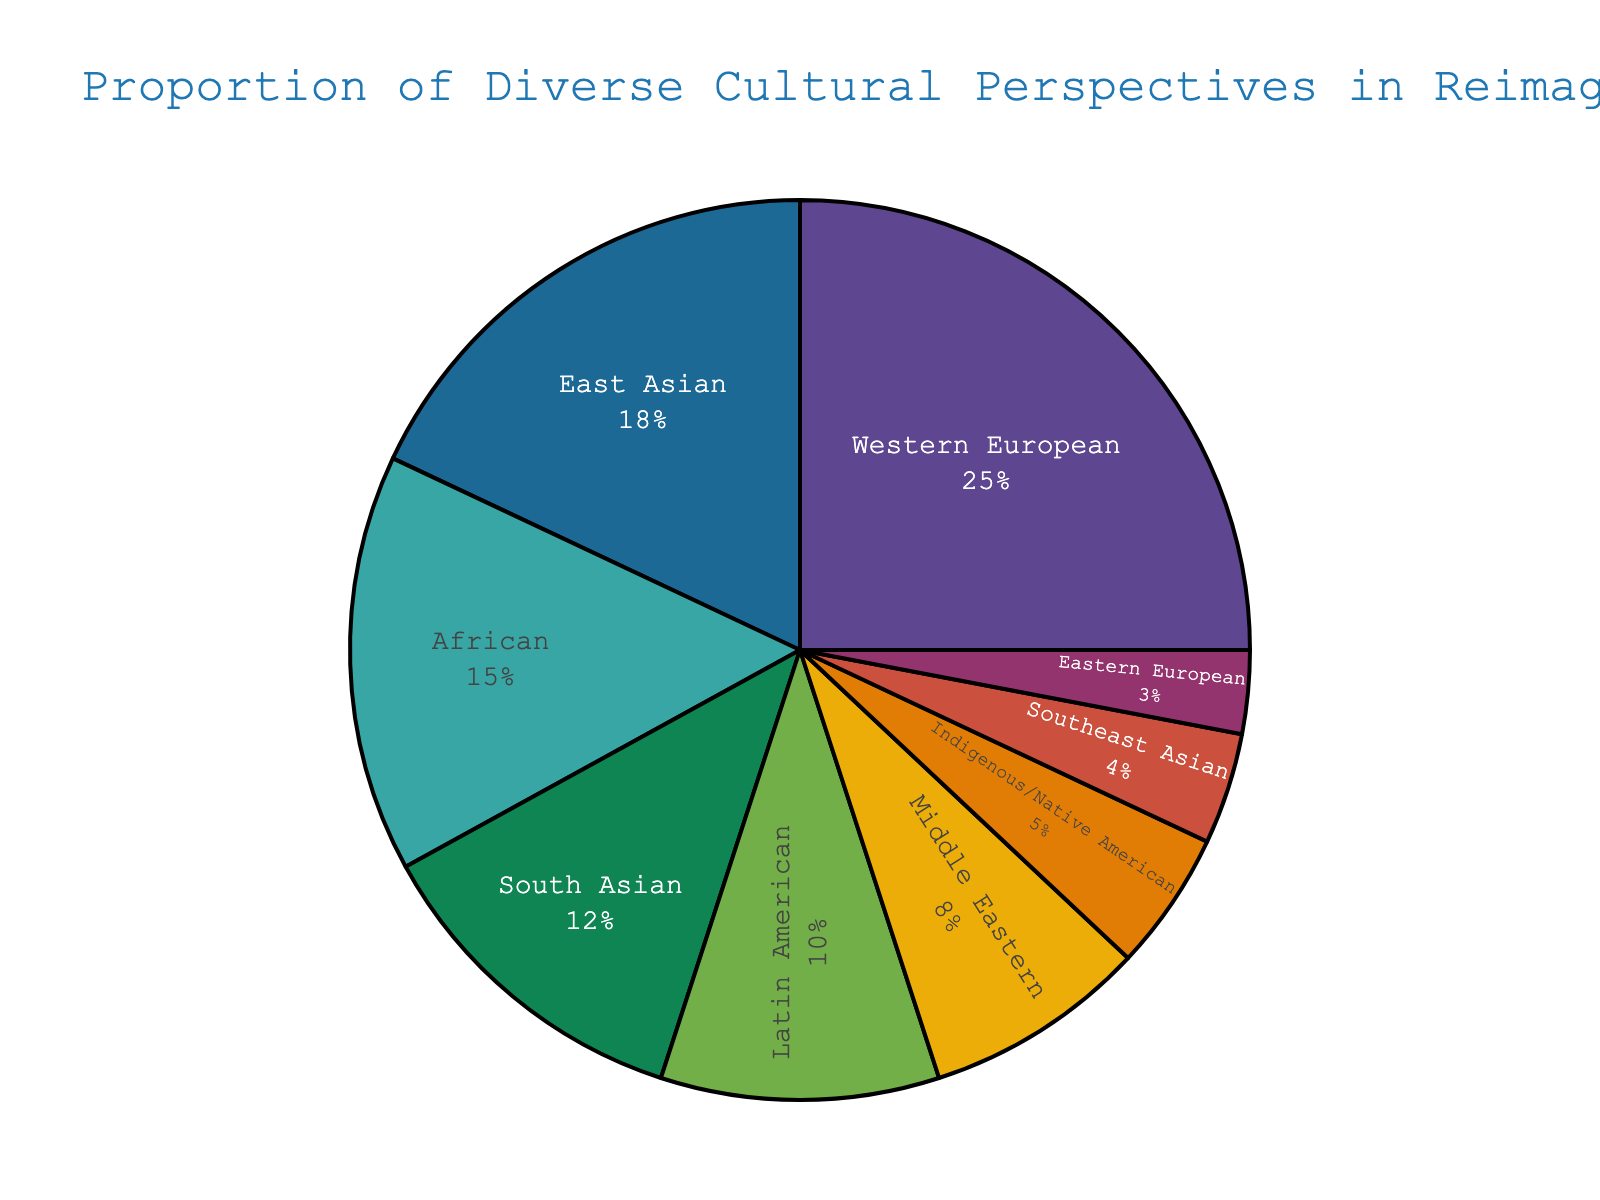What cultural perspective has the highest proportion in the pie chart? To find the cultural perspective with the highest proportion, look at the segment with the largest size in the pie chart. This segment corresponds to Western European with 25%.
Answer: Western European Which cultural perspective has the smallest proportion? To identify the smallest proportion, locate the smallest segment in the pie chart. This segment corresponds to Eastern European with 3%.
Answer: Eastern European What is the combined proportion of Western European and East Asian perspectives? First, find the proportions of Western European (25%) and East Asian (18%) perspectives. Add these two values together: 25% + 18% = 43%.
Answer: 43% How does the proportion of African perspectives compare to that of Latin American perspectives? Look at the segments for African and Latin American perspectives. African is 15%, and Latin American is 10%. 15% is greater than 10%.
Answer: African is greater What is the total proportion of perspectives other than Western European? Find the proportion of Western European, which is 25%. Subtract this from 100% to get the total of other perspectives: 100% - 25% = 75%.
Answer: 75% What is the difference in proportion between South Asian and Middle Eastern perspectives? Look at South Asian (12%) and Middle Eastern (8%). Subtract the smaller from the larger: 12% - 8% = 4%.
Answer: 4% Which perspectives cumulatively make up more than 50% of the chart? Sum the proportions sequentially from highest until the cumulative value exceeds 50%. Western European (25%) + East Asian (18%) = 43%; adding African (15%) = 58%, exceeding 50%. The required perspectives are Western European, East Asian, and African.
Answer: Western European, East Asian, African What is the average proportion of Indigenous/Native American, Southeast Asian, and Eastern European perspectives? Find the proportions: Indigenous/Native American (5%), Southeast Asian (4%), Eastern European (3%). Calculate the average: (5% + 4% + 3%) / 3 = 4%.
Answer: 4% How does the proportion of South Asian perspectives compare to the combined proportion of Southeast Asian and Indigenous/Native American perspectives? Look at South Asian (12%), Southeast Asian (4%), and Indigenous/Native American (5%). Combine Southeast Asian and Indigenous/Native American: 4% + 5% = 9%. Compare 12% to 9%.
Answer: South Asian is greater What proportion of the pie chart is composed of non-Asian perspectives (excluding East Asian, South Asian, and Southeast Asian)? Sum the proportions of all non-Asian perspectives: Western European (25%) + African (15%) + Latin American (10%) + Middle Eastern (8%) + Indigenous/Native American (5%) + Eastern European (3%) = 66%.
Answer: 66% 